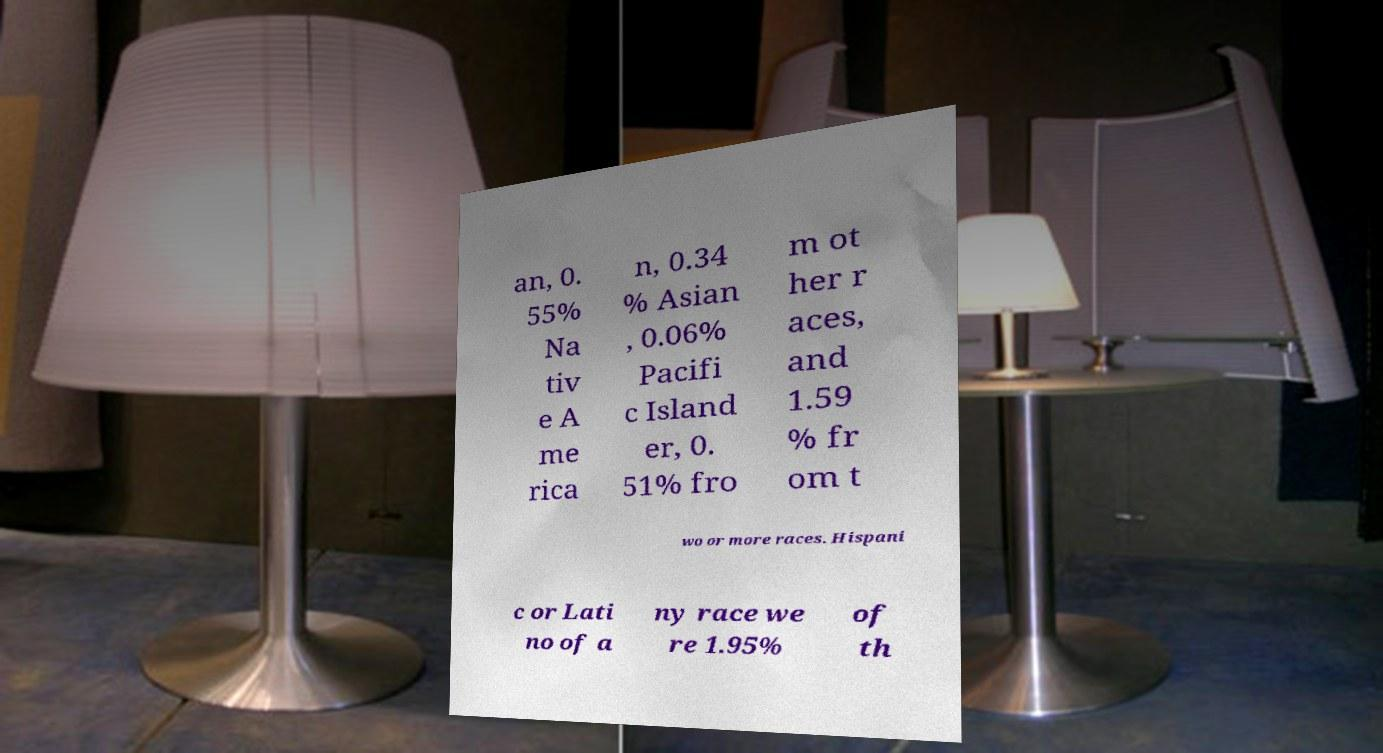Can you accurately transcribe the text from the provided image for me? an, 0. 55% Na tiv e A me rica n, 0.34 % Asian , 0.06% Pacifi c Island er, 0. 51% fro m ot her r aces, and 1.59 % fr om t wo or more races. Hispani c or Lati no of a ny race we re 1.95% of th 